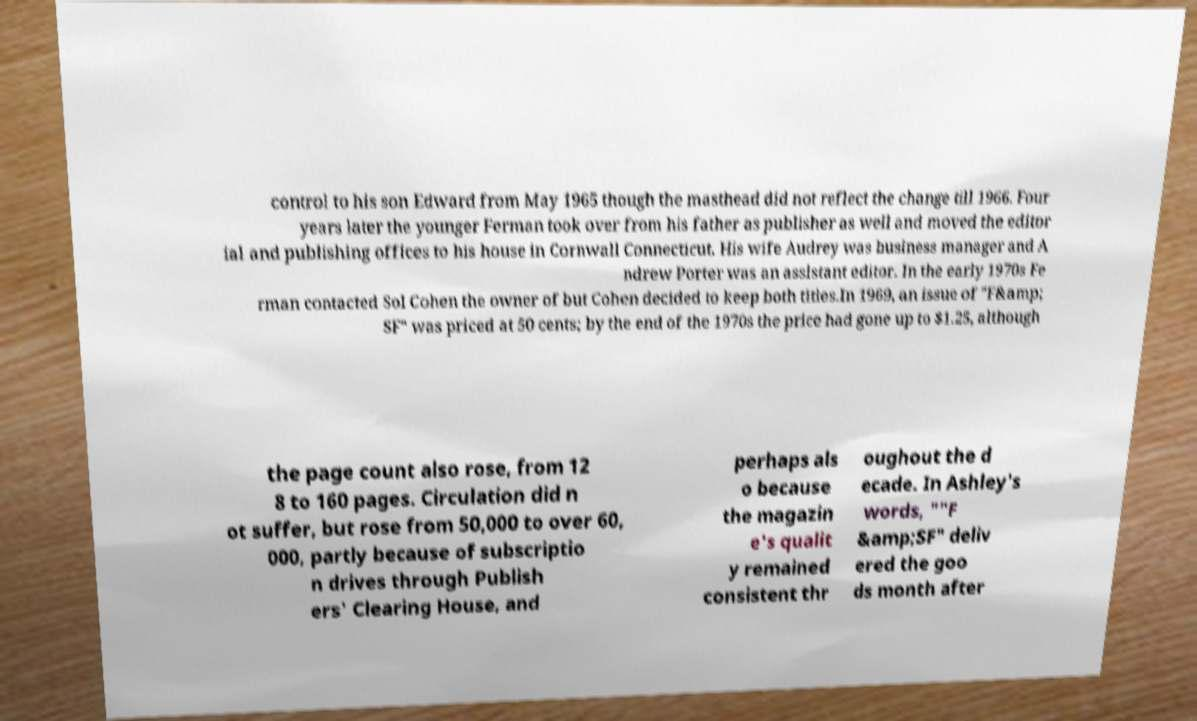What messages or text are displayed in this image? I need them in a readable, typed format. control to his son Edward from May 1965 though the masthead did not reflect the change till 1966. Four years later the younger Ferman took over from his father as publisher as well and moved the editor ial and publishing offices to his house in Cornwall Connecticut. His wife Audrey was business manager and A ndrew Porter was an assistant editor. In the early 1970s Fe rman contacted Sol Cohen the owner of but Cohen decided to keep both titles.In 1969, an issue of "F&amp; SF" was priced at 50 cents; by the end of the 1970s the price had gone up to $1.25, although the page count also rose, from 12 8 to 160 pages. Circulation did n ot suffer, but rose from 50,000 to over 60, 000, partly because of subscriptio n drives through Publish ers' Clearing House, and perhaps als o because the magazin e's qualit y remained consistent thr oughout the d ecade. In Ashley's words, ""F &amp;SF" deliv ered the goo ds month after 